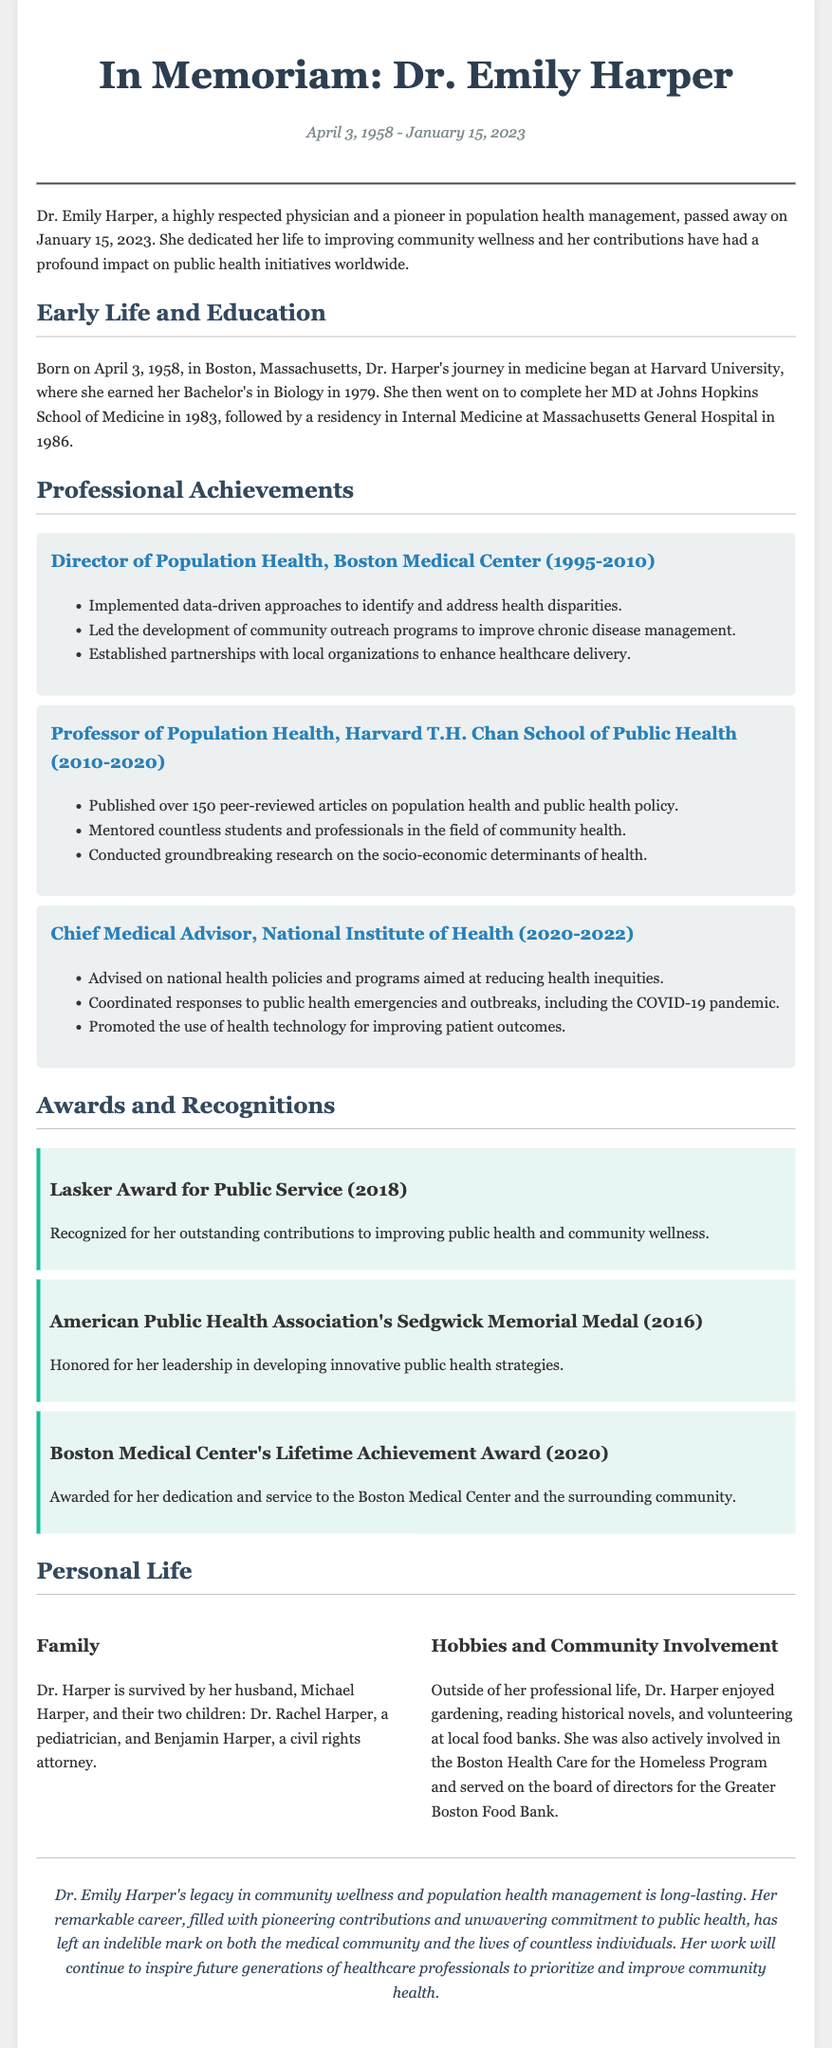what was Dr. Emily Harper's birth date? The document states that Dr. Emily Harper was born on April 3, 1958.
Answer: April 3, 1958 what university did Dr. Harper complete her MD? The document mentions that she completed her MD at Johns Hopkins School of Medicine.
Answer: Johns Hopkins School of Medicine which award did Dr. Harper receive in 2018? The document lists the Lasker Award for Public Service as the award she received in 2018.
Answer: Lasker Award for Public Service how many peer-reviewed articles did Dr. Harper publish? The obituary states Dr. Harper published over 150 peer-reviewed articles.
Answer: over 150 what was Dr. Harper's role from 1995 to 2010? The document outlines that she was the Director of Population Health at Boston Medical Center during this period.
Answer: Director of Population Health which program was Dr. Harper actively involved in? The document states she was actively involved in the Boston Health Care for the Homeless Program.
Answer: Boston Health Care for the Homeless Program what hobbies did Dr. Harper enjoy? The document lists gardening, reading historical novels, and volunteering at local food banks as her hobbies.
Answer: gardening, reading historical novels, volunteering at local food banks what is the legacy of Dr. Harper described in the conclusion? The conclusion reflects on her legacy being long-lasting in community wellness and population health management.
Answer: long-lasting in community wellness and population health management 